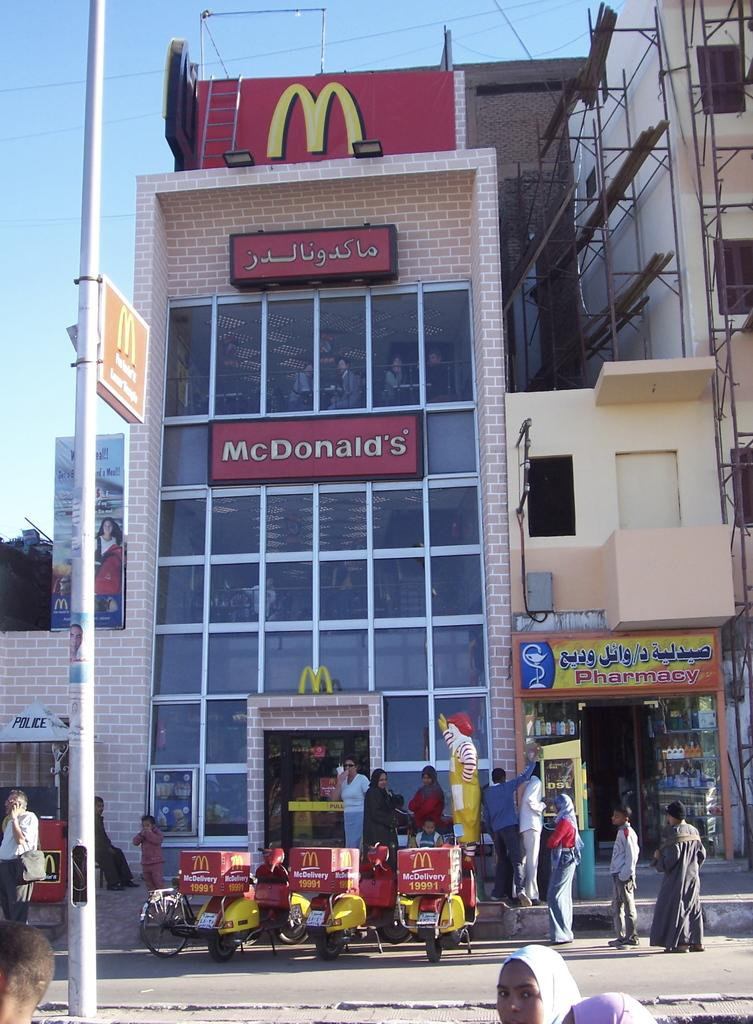<image>
Summarize the visual content of the image. A two story fast food McDonald's restaurant next to a pharmacy. 